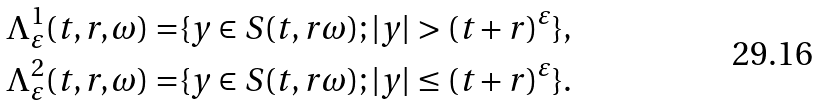Convert formula to latex. <formula><loc_0><loc_0><loc_500><loc_500>\Lambda _ { \varepsilon } ^ { 1 } ( t , r , \omega ) = & \{ y \in S ( t , r \omega ) ; | y | > ( t + r ) ^ { \varepsilon } \} , \\ \Lambda _ { \varepsilon } ^ { 2 } ( t , r , \omega ) = & \{ y \in S ( t , r \omega ) ; | y | \leq ( t + r ) ^ { \varepsilon } \} .</formula> 